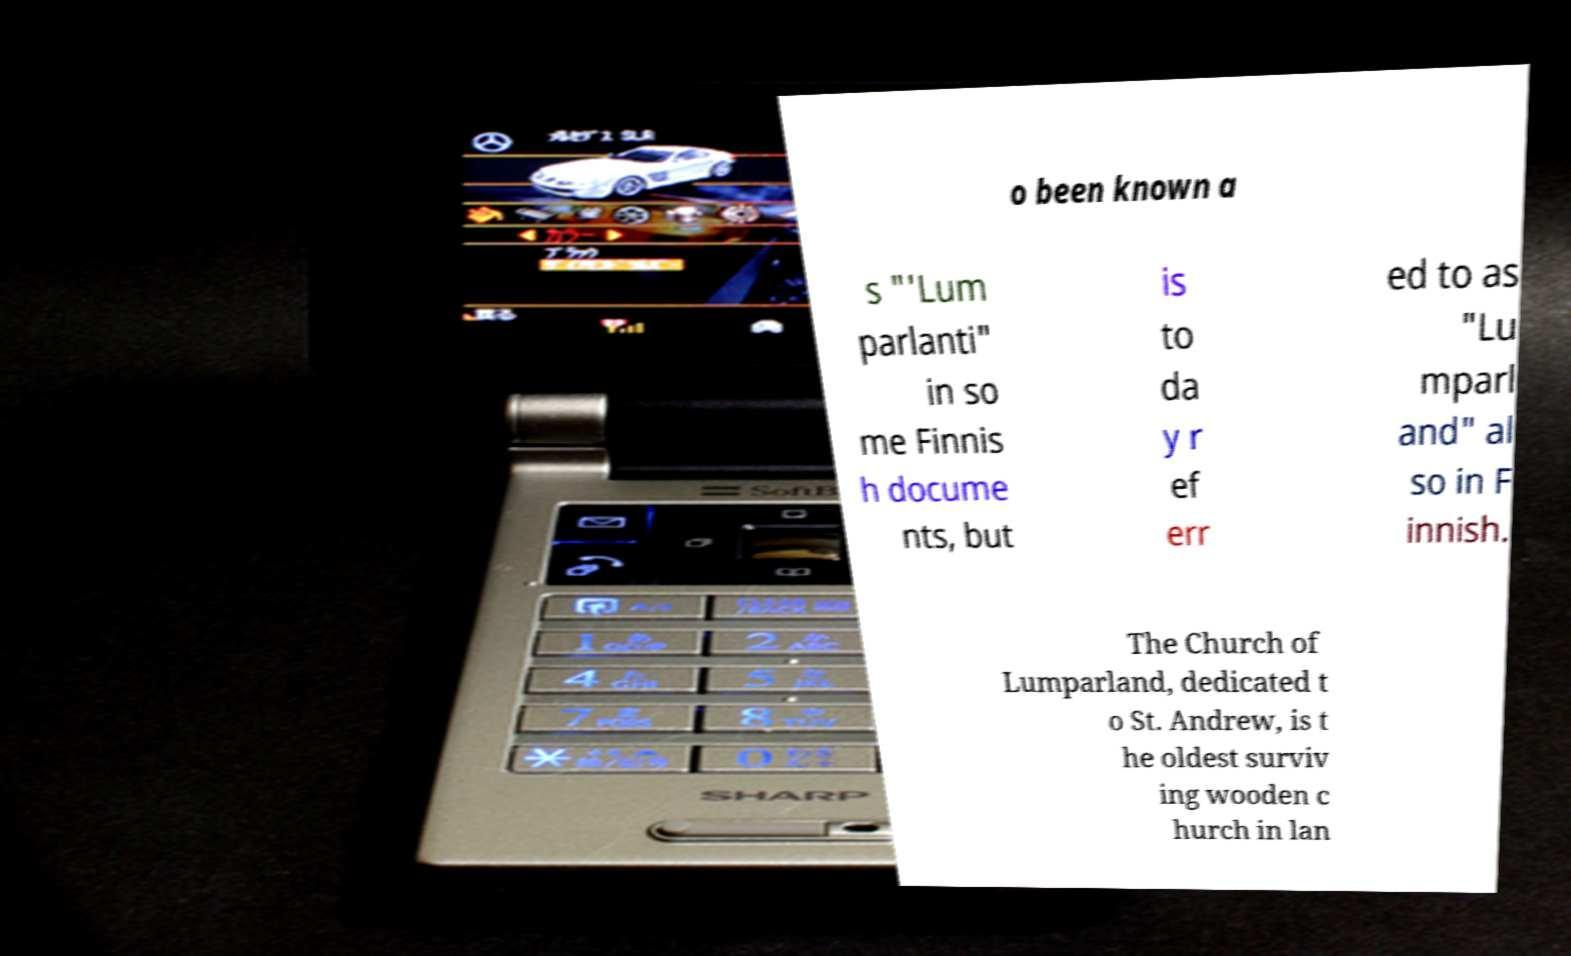Please identify and transcribe the text found in this image. o been known a s "'Lum parlanti" in so me Finnis h docume nts, but is to da y r ef err ed to as "Lu mparl and" al so in F innish. The Church of Lumparland, dedicated t o St. Andrew, is t he oldest surviv ing wooden c hurch in lan 